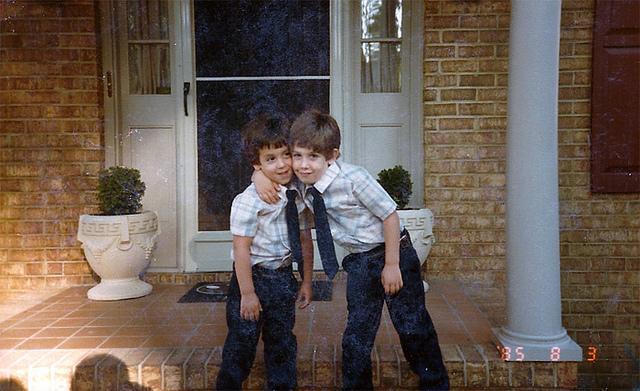How many potted plants are in the picture?
Give a very brief answer. 2. How many people are in the photo?
Give a very brief answer. 2. 